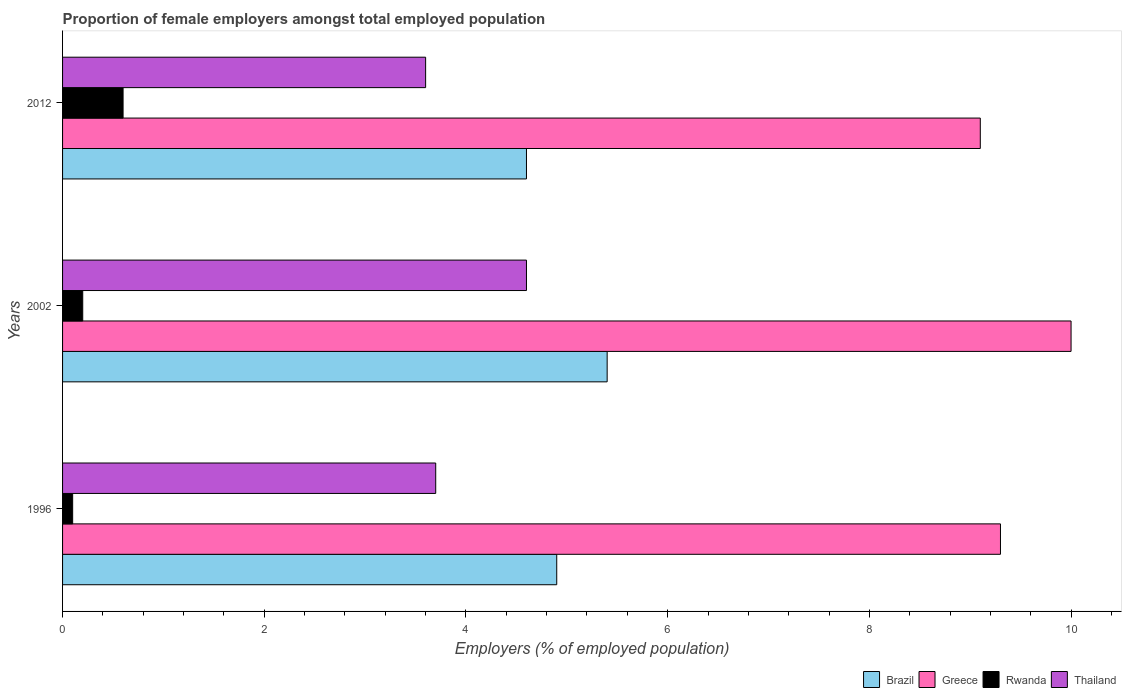How many different coloured bars are there?
Make the answer very short. 4. How many groups of bars are there?
Your response must be concise. 3. Are the number of bars per tick equal to the number of legend labels?
Give a very brief answer. Yes. What is the label of the 3rd group of bars from the top?
Your answer should be very brief. 1996. In how many cases, is the number of bars for a given year not equal to the number of legend labels?
Ensure brevity in your answer.  0. What is the proportion of female employers in Greece in 2002?
Provide a succinct answer. 10. Across all years, what is the maximum proportion of female employers in Rwanda?
Offer a very short reply. 0.6. Across all years, what is the minimum proportion of female employers in Greece?
Ensure brevity in your answer.  9.1. In which year was the proportion of female employers in Thailand maximum?
Offer a very short reply. 2002. In which year was the proportion of female employers in Brazil minimum?
Give a very brief answer. 2012. What is the total proportion of female employers in Rwanda in the graph?
Offer a terse response. 0.9. What is the difference between the proportion of female employers in Thailand in 1996 and that in 2012?
Give a very brief answer. 0.1. What is the difference between the proportion of female employers in Thailand in 1996 and the proportion of female employers in Rwanda in 2012?
Keep it short and to the point. 3.1. What is the average proportion of female employers in Rwanda per year?
Give a very brief answer. 0.3. In the year 1996, what is the difference between the proportion of female employers in Thailand and proportion of female employers in Greece?
Your answer should be very brief. -5.6. What is the ratio of the proportion of female employers in Greece in 2002 to that in 2012?
Offer a very short reply. 1.1. Is the difference between the proportion of female employers in Thailand in 1996 and 2002 greater than the difference between the proportion of female employers in Greece in 1996 and 2002?
Offer a terse response. No. What is the difference between the highest and the second highest proportion of female employers in Brazil?
Offer a terse response. 0.5. What is the difference between the highest and the lowest proportion of female employers in Rwanda?
Make the answer very short. 0.5. In how many years, is the proportion of female employers in Brazil greater than the average proportion of female employers in Brazil taken over all years?
Your response must be concise. 1. What does the 4th bar from the top in 2012 represents?
Your answer should be very brief. Brazil. What does the 3rd bar from the bottom in 2012 represents?
Your answer should be very brief. Rwanda. What is the difference between two consecutive major ticks on the X-axis?
Provide a short and direct response. 2. Are the values on the major ticks of X-axis written in scientific E-notation?
Your answer should be very brief. No. Does the graph contain grids?
Give a very brief answer. No. How are the legend labels stacked?
Offer a terse response. Horizontal. What is the title of the graph?
Provide a short and direct response. Proportion of female employers amongst total employed population. What is the label or title of the X-axis?
Offer a terse response. Employers (% of employed population). What is the label or title of the Y-axis?
Your response must be concise. Years. What is the Employers (% of employed population) of Brazil in 1996?
Give a very brief answer. 4.9. What is the Employers (% of employed population) in Greece in 1996?
Ensure brevity in your answer.  9.3. What is the Employers (% of employed population) of Rwanda in 1996?
Your answer should be very brief. 0.1. What is the Employers (% of employed population) of Thailand in 1996?
Offer a terse response. 3.7. What is the Employers (% of employed population) in Brazil in 2002?
Offer a very short reply. 5.4. What is the Employers (% of employed population) of Rwanda in 2002?
Offer a very short reply. 0.2. What is the Employers (% of employed population) in Thailand in 2002?
Ensure brevity in your answer.  4.6. What is the Employers (% of employed population) of Brazil in 2012?
Offer a very short reply. 4.6. What is the Employers (% of employed population) of Greece in 2012?
Give a very brief answer. 9.1. What is the Employers (% of employed population) in Rwanda in 2012?
Provide a short and direct response. 0.6. What is the Employers (% of employed population) of Thailand in 2012?
Your answer should be compact. 3.6. Across all years, what is the maximum Employers (% of employed population) of Brazil?
Give a very brief answer. 5.4. Across all years, what is the maximum Employers (% of employed population) in Rwanda?
Keep it short and to the point. 0.6. Across all years, what is the maximum Employers (% of employed population) in Thailand?
Make the answer very short. 4.6. Across all years, what is the minimum Employers (% of employed population) of Brazil?
Keep it short and to the point. 4.6. Across all years, what is the minimum Employers (% of employed population) of Greece?
Your answer should be very brief. 9.1. Across all years, what is the minimum Employers (% of employed population) of Rwanda?
Ensure brevity in your answer.  0.1. Across all years, what is the minimum Employers (% of employed population) in Thailand?
Your answer should be compact. 3.6. What is the total Employers (% of employed population) of Greece in the graph?
Your response must be concise. 28.4. What is the total Employers (% of employed population) in Rwanda in the graph?
Offer a terse response. 0.9. What is the total Employers (% of employed population) in Thailand in the graph?
Your answer should be very brief. 11.9. What is the difference between the Employers (% of employed population) in Brazil in 1996 and that in 2002?
Give a very brief answer. -0.5. What is the difference between the Employers (% of employed population) in Greece in 1996 and that in 2002?
Provide a succinct answer. -0.7. What is the difference between the Employers (% of employed population) in Rwanda in 1996 and that in 2002?
Provide a short and direct response. -0.1. What is the difference between the Employers (% of employed population) of Thailand in 1996 and that in 2002?
Offer a very short reply. -0.9. What is the difference between the Employers (% of employed population) in Greece in 1996 and that in 2012?
Give a very brief answer. 0.2. What is the difference between the Employers (% of employed population) of Rwanda in 1996 and that in 2012?
Your answer should be very brief. -0.5. What is the difference between the Employers (% of employed population) of Rwanda in 2002 and that in 2012?
Give a very brief answer. -0.4. What is the difference between the Employers (% of employed population) of Thailand in 2002 and that in 2012?
Keep it short and to the point. 1. What is the difference between the Employers (% of employed population) in Brazil in 1996 and the Employers (% of employed population) in Thailand in 2002?
Provide a succinct answer. 0.3. What is the difference between the Employers (% of employed population) of Greece in 1996 and the Employers (% of employed population) of Rwanda in 2002?
Ensure brevity in your answer.  9.1. What is the difference between the Employers (% of employed population) of Greece in 1996 and the Employers (% of employed population) of Thailand in 2002?
Offer a very short reply. 4.7. What is the difference between the Employers (% of employed population) in Rwanda in 1996 and the Employers (% of employed population) in Thailand in 2002?
Offer a very short reply. -4.5. What is the difference between the Employers (% of employed population) in Brazil in 1996 and the Employers (% of employed population) in Rwanda in 2012?
Provide a short and direct response. 4.3. What is the difference between the Employers (% of employed population) in Brazil in 1996 and the Employers (% of employed population) in Thailand in 2012?
Keep it short and to the point. 1.3. What is the difference between the Employers (% of employed population) of Rwanda in 1996 and the Employers (% of employed population) of Thailand in 2012?
Ensure brevity in your answer.  -3.5. What is the difference between the Employers (% of employed population) in Greece in 2002 and the Employers (% of employed population) in Rwanda in 2012?
Your response must be concise. 9.4. What is the difference between the Employers (% of employed population) of Greece in 2002 and the Employers (% of employed population) of Thailand in 2012?
Ensure brevity in your answer.  6.4. What is the difference between the Employers (% of employed population) in Rwanda in 2002 and the Employers (% of employed population) in Thailand in 2012?
Make the answer very short. -3.4. What is the average Employers (% of employed population) in Brazil per year?
Make the answer very short. 4.97. What is the average Employers (% of employed population) of Greece per year?
Offer a very short reply. 9.47. What is the average Employers (% of employed population) of Rwanda per year?
Ensure brevity in your answer.  0.3. What is the average Employers (% of employed population) in Thailand per year?
Your answer should be very brief. 3.97. In the year 1996, what is the difference between the Employers (% of employed population) of Brazil and Employers (% of employed population) of Greece?
Give a very brief answer. -4.4. In the year 1996, what is the difference between the Employers (% of employed population) in Brazil and Employers (% of employed population) in Rwanda?
Ensure brevity in your answer.  4.8. In the year 1996, what is the difference between the Employers (% of employed population) in Greece and Employers (% of employed population) in Thailand?
Your response must be concise. 5.6. In the year 2002, what is the difference between the Employers (% of employed population) of Greece and Employers (% of employed population) of Rwanda?
Offer a very short reply. 9.8. In the year 2012, what is the difference between the Employers (% of employed population) in Brazil and Employers (% of employed population) in Greece?
Offer a terse response. -4.5. In the year 2012, what is the difference between the Employers (% of employed population) in Brazil and Employers (% of employed population) in Rwanda?
Offer a terse response. 4. In the year 2012, what is the difference between the Employers (% of employed population) of Brazil and Employers (% of employed population) of Thailand?
Offer a very short reply. 1. What is the ratio of the Employers (% of employed population) in Brazil in 1996 to that in 2002?
Provide a short and direct response. 0.91. What is the ratio of the Employers (% of employed population) in Rwanda in 1996 to that in 2002?
Ensure brevity in your answer.  0.5. What is the ratio of the Employers (% of employed population) of Thailand in 1996 to that in 2002?
Your response must be concise. 0.8. What is the ratio of the Employers (% of employed population) in Brazil in 1996 to that in 2012?
Provide a succinct answer. 1.07. What is the ratio of the Employers (% of employed population) of Rwanda in 1996 to that in 2012?
Offer a terse response. 0.17. What is the ratio of the Employers (% of employed population) in Thailand in 1996 to that in 2012?
Provide a short and direct response. 1.03. What is the ratio of the Employers (% of employed population) of Brazil in 2002 to that in 2012?
Your answer should be very brief. 1.17. What is the ratio of the Employers (% of employed population) of Greece in 2002 to that in 2012?
Your answer should be compact. 1.1. What is the ratio of the Employers (% of employed population) of Thailand in 2002 to that in 2012?
Your response must be concise. 1.28. What is the difference between the highest and the second highest Employers (% of employed population) of Brazil?
Your response must be concise. 0.5. What is the difference between the highest and the second highest Employers (% of employed population) in Rwanda?
Provide a succinct answer. 0.4. What is the difference between the highest and the second highest Employers (% of employed population) of Thailand?
Your answer should be compact. 0.9. What is the difference between the highest and the lowest Employers (% of employed population) in Thailand?
Make the answer very short. 1. 